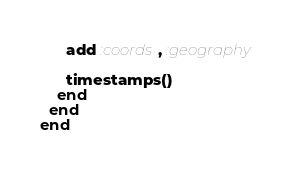<code> <loc_0><loc_0><loc_500><loc_500><_Elixir_>      add :coords, :geography

      timestamps()
    end
  end
end
</code> 